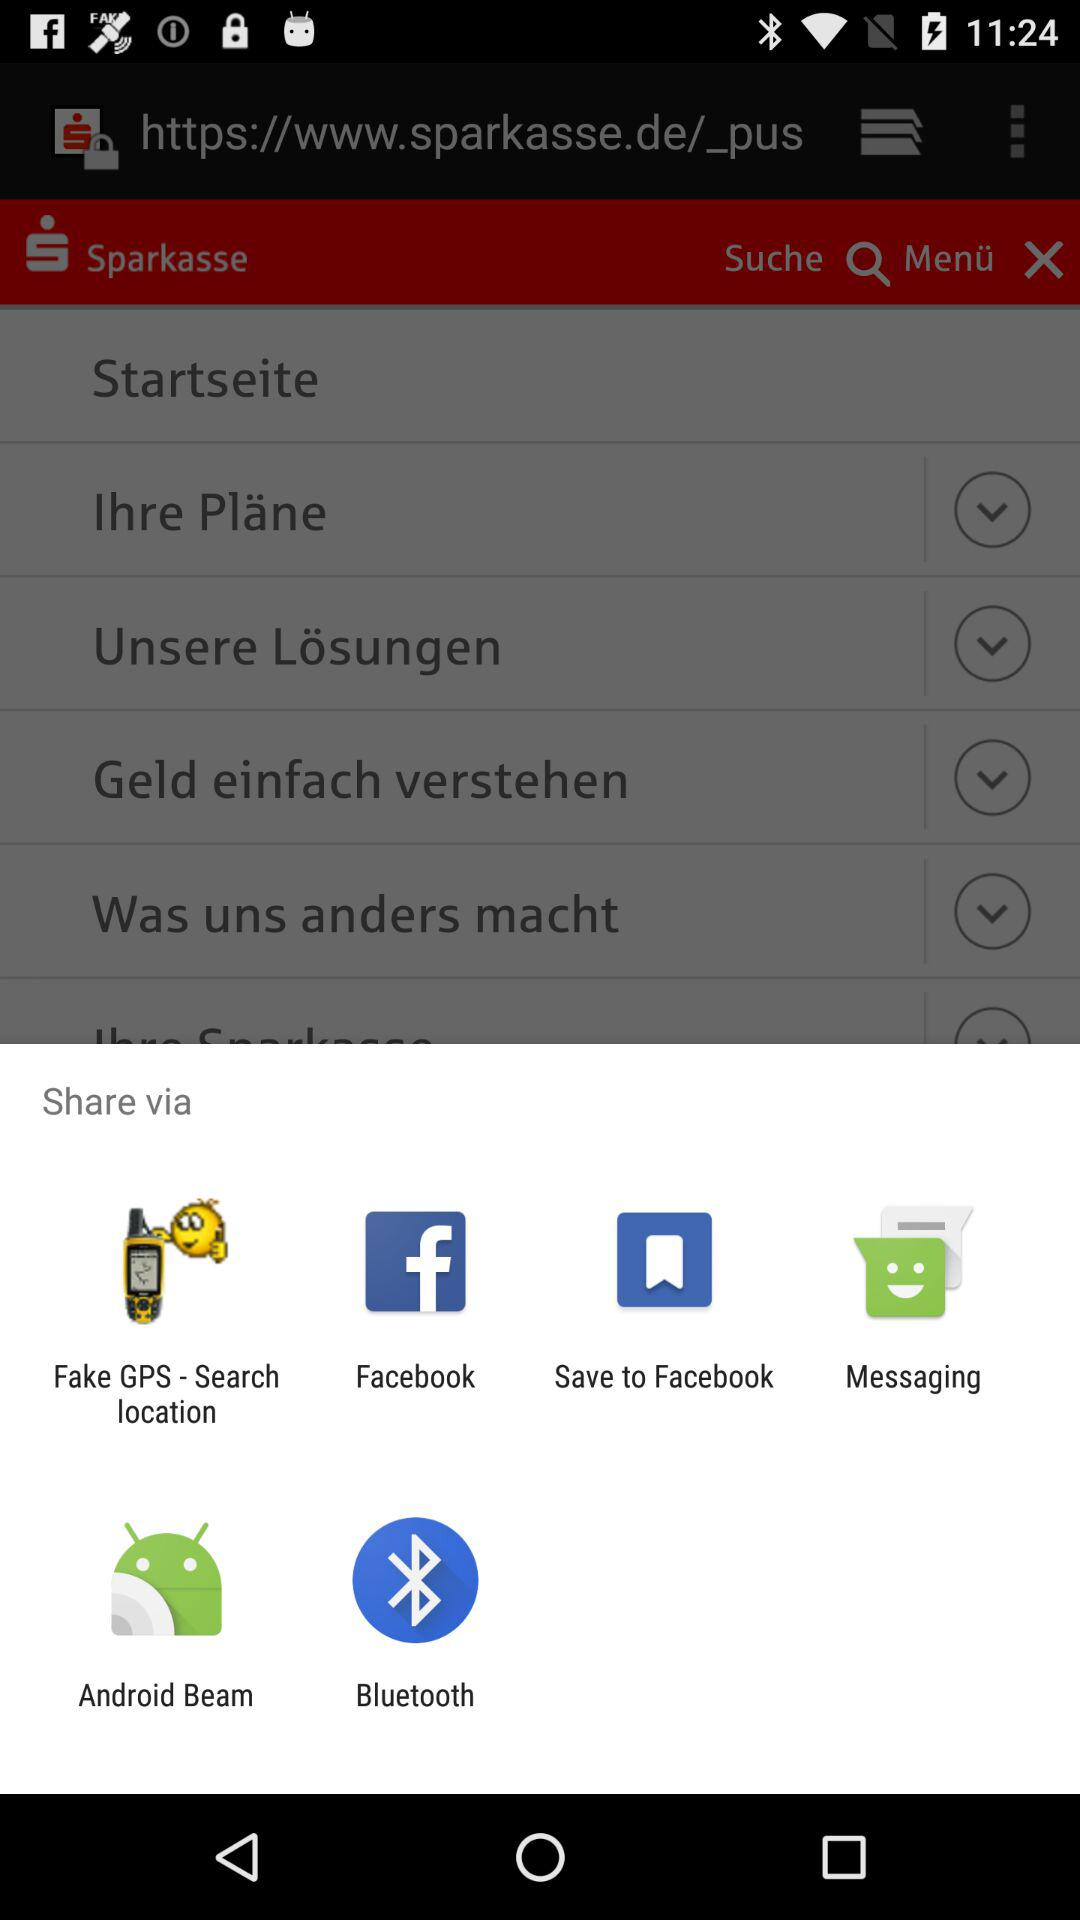What applications can be used to share? The applications "Fake GPS - Search location", "Facebook", "Save to Facebook", "Messaging", "Android Beam" and "Bluetooth" can be used to share. 